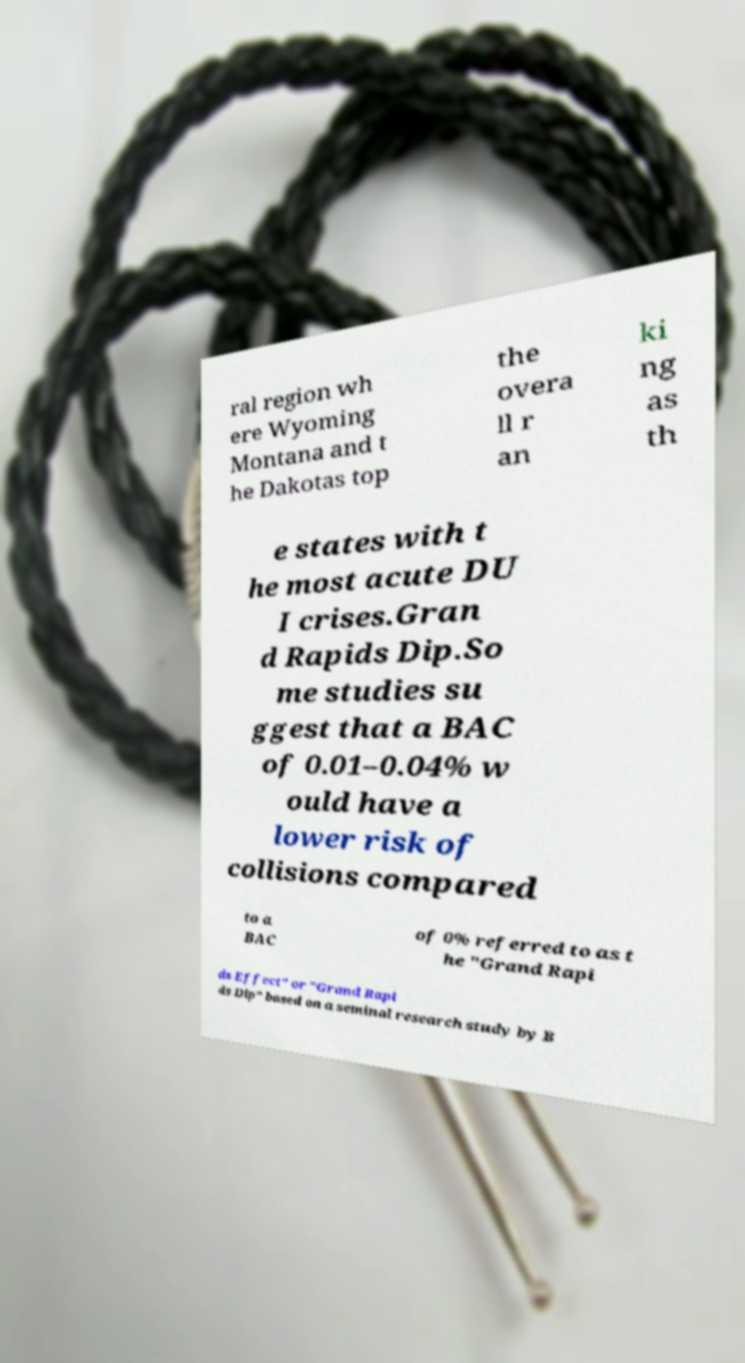Could you assist in decoding the text presented in this image and type it out clearly? ral region wh ere Wyoming Montana and t he Dakotas top the overa ll r an ki ng as th e states with t he most acute DU I crises.Gran d Rapids Dip.So me studies su ggest that a BAC of 0.01–0.04% w ould have a lower risk of collisions compared to a BAC of 0% referred to as t he "Grand Rapi ds Effect" or "Grand Rapi ds Dip" based on a seminal research study by B 